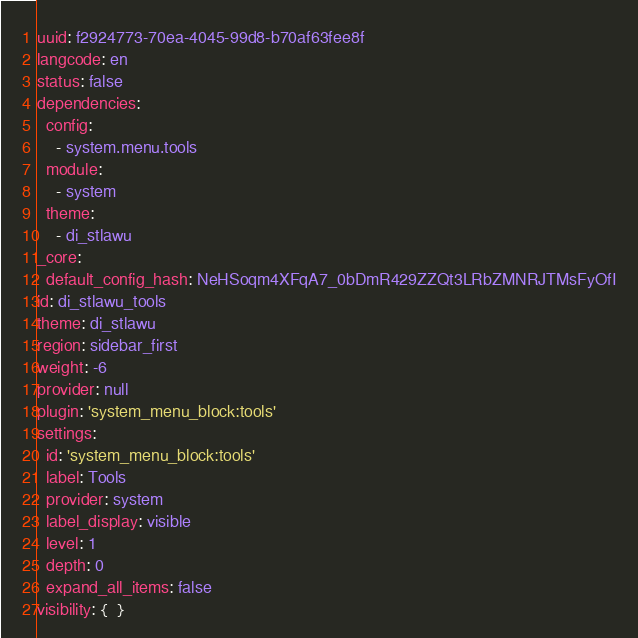Convert code to text. <code><loc_0><loc_0><loc_500><loc_500><_YAML_>uuid: f2924773-70ea-4045-99d8-b70af63fee8f
langcode: en
status: false
dependencies:
  config:
    - system.menu.tools
  module:
    - system
  theme:
    - di_stlawu
_core:
  default_config_hash: NeHSoqm4XFqA7_0bDmR429ZZQt3LRbZMNRJTMsFyOfI
id: di_stlawu_tools
theme: di_stlawu
region: sidebar_first
weight: -6
provider: null
plugin: 'system_menu_block:tools'
settings:
  id: 'system_menu_block:tools'
  label: Tools
  provider: system
  label_display: visible
  level: 1
  depth: 0
  expand_all_items: false
visibility: {  }
</code> 